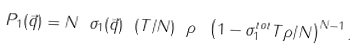Convert formula to latex. <formula><loc_0><loc_0><loc_500><loc_500>P _ { 1 } ( \vec { q } ) = N \ \sigma _ { 1 } ( \vec { q } ) \ ( T / N ) \ \rho \ \left ( 1 - \sigma _ { 1 } ^ { t o t } T \rho / N \right ) ^ { N - 1 } .</formula> 